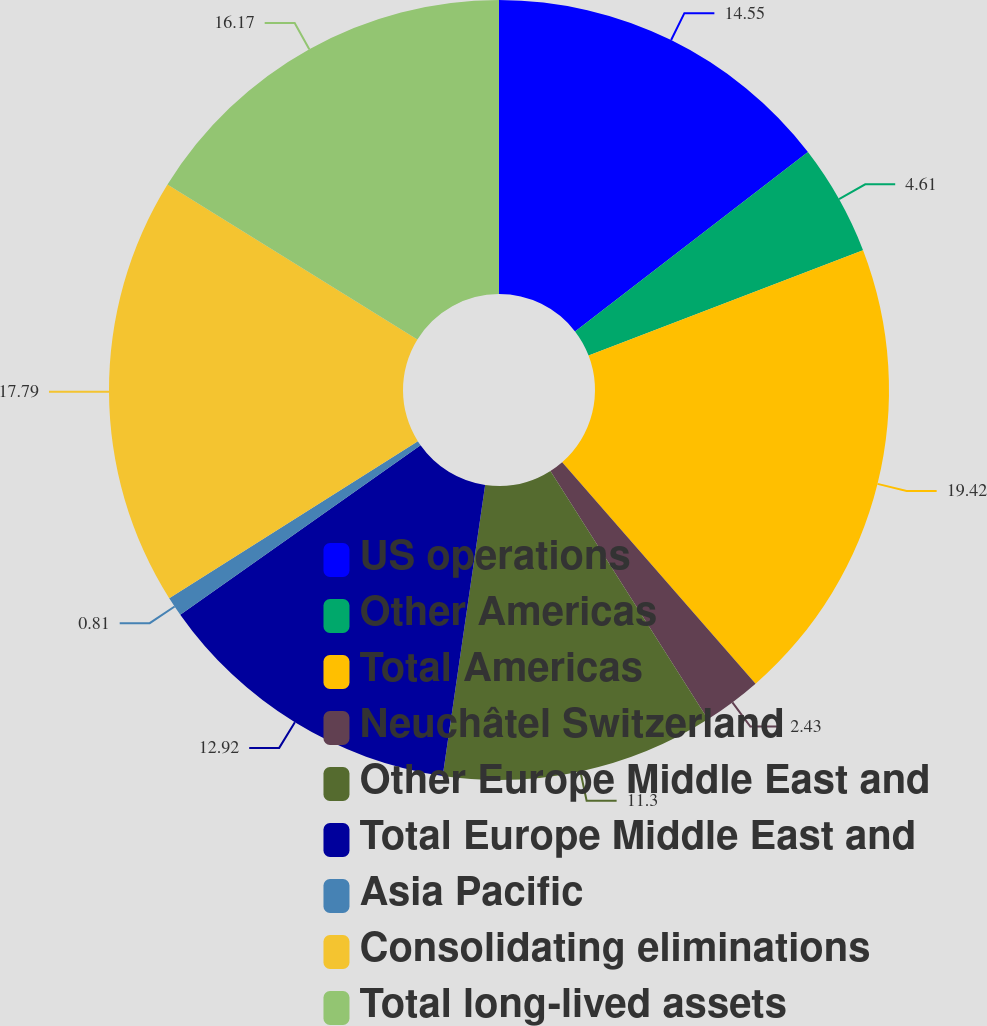Convert chart to OTSL. <chart><loc_0><loc_0><loc_500><loc_500><pie_chart><fcel>US operations<fcel>Other Americas<fcel>Total Americas<fcel>Neuchâtel Switzerland<fcel>Other Europe Middle East and<fcel>Total Europe Middle East and<fcel>Asia Pacific<fcel>Consolidating eliminations<fcel>Total long-lived assets<nl><fcel>14.55%<fcel>4.61%<fcel>19.41%<fcel>2.43%<fcel>11.3%<fcel>12.92%<fcel>0.81%<fcel>17.79%<fcel>16.17%<nl></chart> 